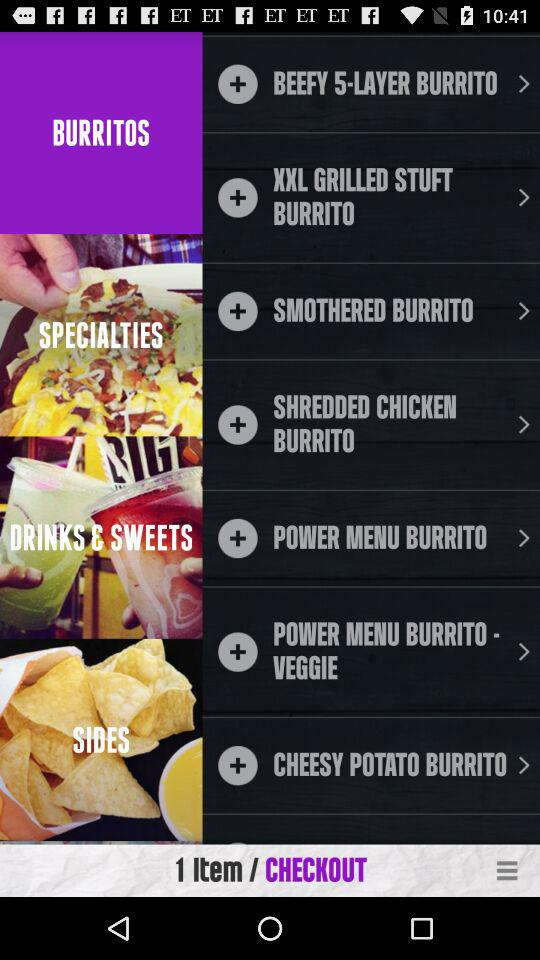How many items are in the shopping cart?
Answer the question using a single word or phrase. 1 